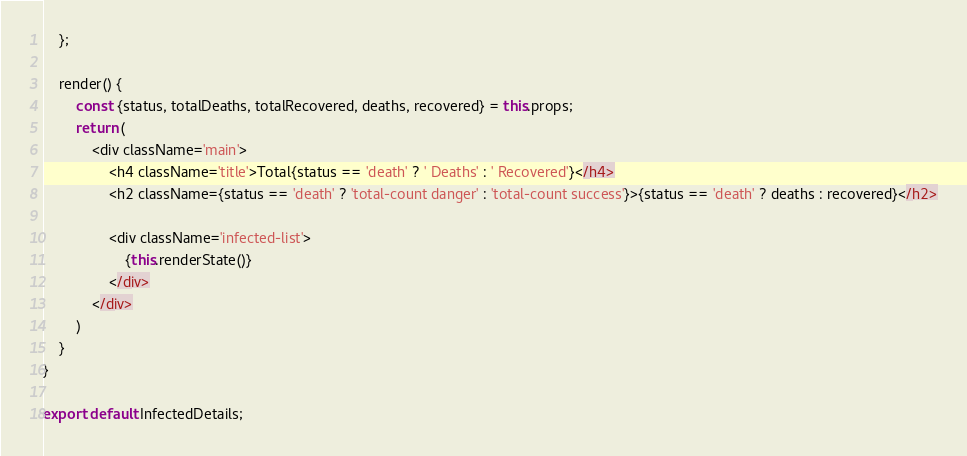Convert code to text. <code><loc_0><loc_0><loc_500><loc_500><_JavaScript_>    };

    render() {
        const {status, totalDeaths, totalRecovered, deaths, recovered} = this.props;
        return (
            <div className='main'>
                <h4 className='title'>Total{status == 'death' ? ' Deaths' : ' Recovered'}</h4>
                <h2 className={status == 'death' ? 'total-count danger' : 'total-count success'}>{status == 'death' ? deaths : recovered}</h2>

                <div className='infected-list'>
                    {this.renderState()}
                </div>
            </div>
        )
    }
}

export default InfectedDetails;
</code> 